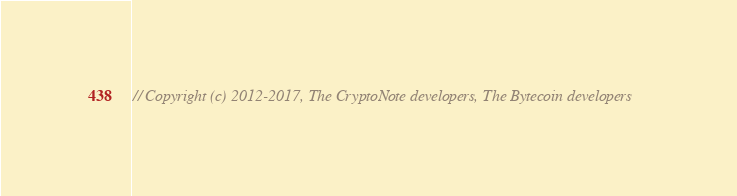Convert code to text. <code><loc_0><loc_0><loc_500><loc_500><_C++_>// Copyright (c) 2012-2017, The CryptoNote developers, The Bytecoin developers</code> 